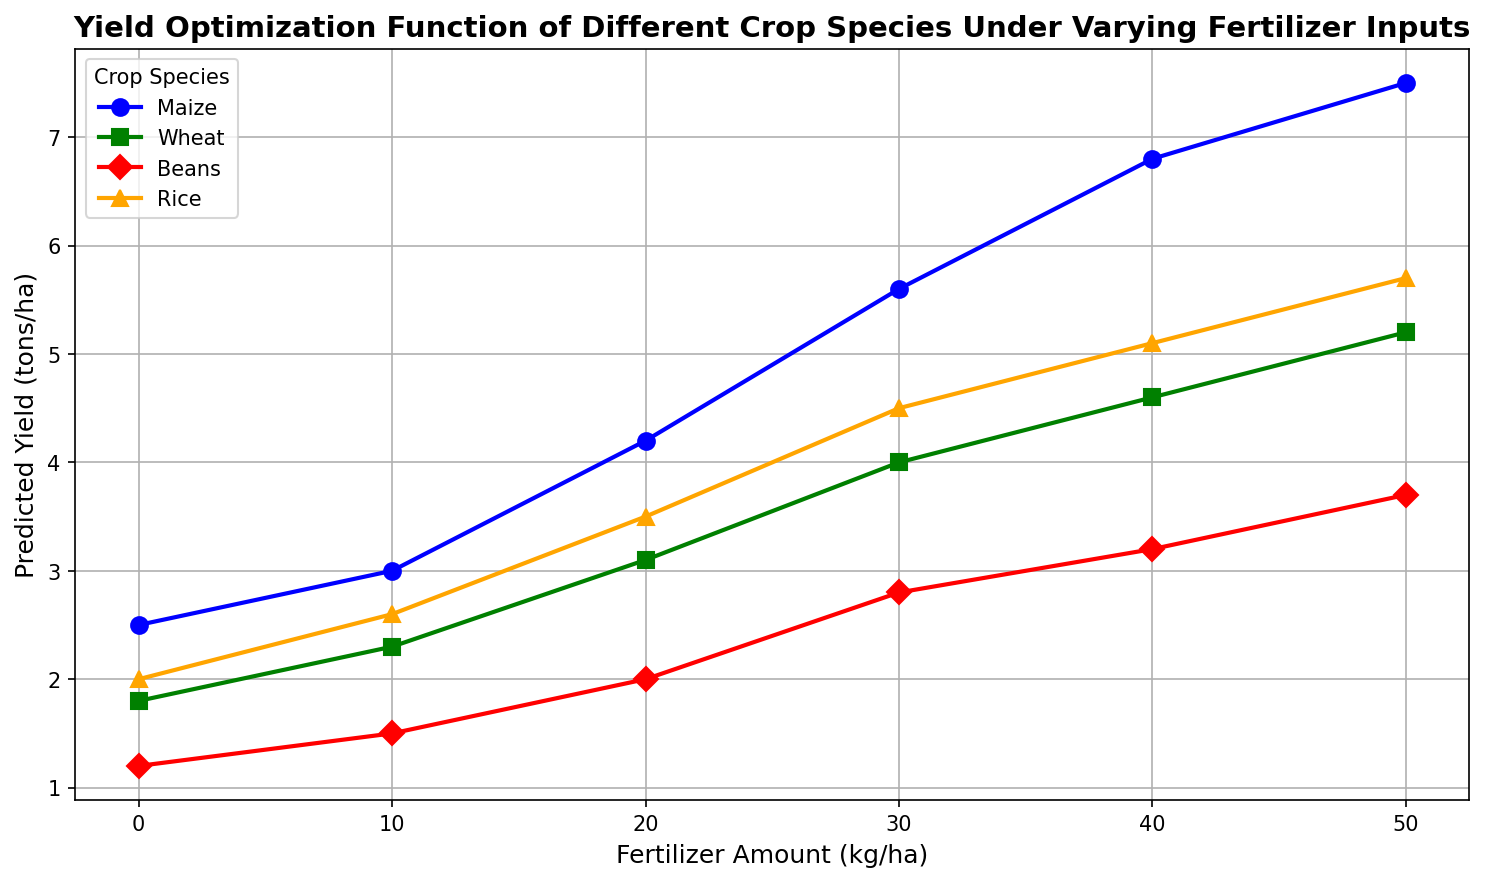What is the maize's predicted yield at 30 kg/ha of fertilizer? Look for the data point where the fertilizer amount is 30 kg/ha on the maize line. The predicted yield at that point is 5.6 tons/ha.
Answer: 5.6 tons/ha Which crop species has the highest yield at 50 kg/ha of fertilizer? Compare the endpoints of each crop's line at 50 kg/ha. Maize has the highest predicted yield at 7.5 tons/ha.
Answer: Maize How much more yield does wheat have compared to beans at 20 kg/ha of fertilizer? Find the predicted yields for wheat and beans at 20 kg/ha and subtract the yield of beans from that of wheat: 3.1 - 2.0 = 1.1 tons/ha.
Answer: 1.1 tons/ha What is the average predicted yield across all crop species at 40 kg/ha of fertilizer? Find the predicted yields for maize, wheat, beans, and rice at 40 kg/ha, sum them up, and divide by the number of crop species: (6.8 + 4.6 + 3.2 + 5.1) / 4 = 4.925 tons/ha.
Answer: 4.9 tons/ha Is the yield increase from 0 to 10 kg/ha of fertilizer greater for maize or rice? Compare the increase in yield for maize (3.0 - 2.5 = 0.5 tons/ha) and for rice (2.6 - 2.0 = 0.6 tons/ha). Rice has a greater increase.
Answer: Rice By how much does maize's yield increase from 20 to 40 kg/ha of fertilizer? Subtract the yield at 20 kg/ha from the yield at 40 kg/ha for maize: 6.8 - 4.2 = 2.6 tons/ha.
Answer: 2.6 tons/ha Which crop has the steepest increase in yield between 20 and 30 kg/ha of fertilizer? Compare the yield differences between 20 and 30 kg/ha for all crops. Maize has the highest increase of 1.4 tons/ha (5.6 - 4.2).
Answer: Maize Does beans' yield reach above 3.0 tons/ha, and if so, at what fertilizer amount does it first achieve this? Look for the data point where beans' yield first exceeds 3.0 tons/ha. At 30 kg/ha, the yield is 3.2 tons/ha.
Answer: Yes, 30 kg/ha How much higher is the rice's yield at 50 kg/ha of fertilizer compared to 30 kg/ha? Subtract the rice yield at 30 kg/ha from the yield at 50 kg/ha: 5.7 - 4.5 = 1.2 tons/ha.
Answer: 1.2 tons/ha 